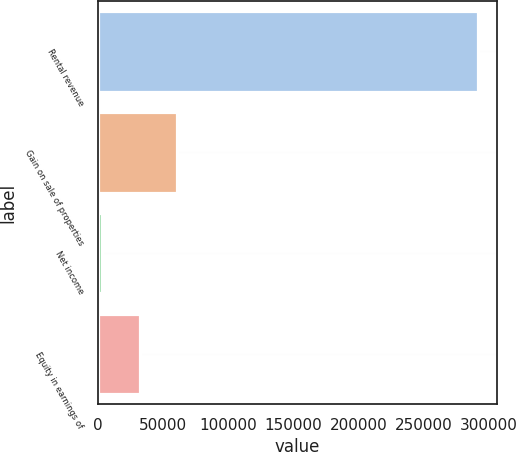Convert chart. <chart><loc_0><loc_0><loc_500><loc_500><bar_chart><fcel>Rental revenue<fcel>Gain on sale of properties<fcel>Net income<fcel>Equity in earnings of<nl><fcel>291534<fcel>60806.8<fcel>3125<fcel>31965.9<nl></chart> 